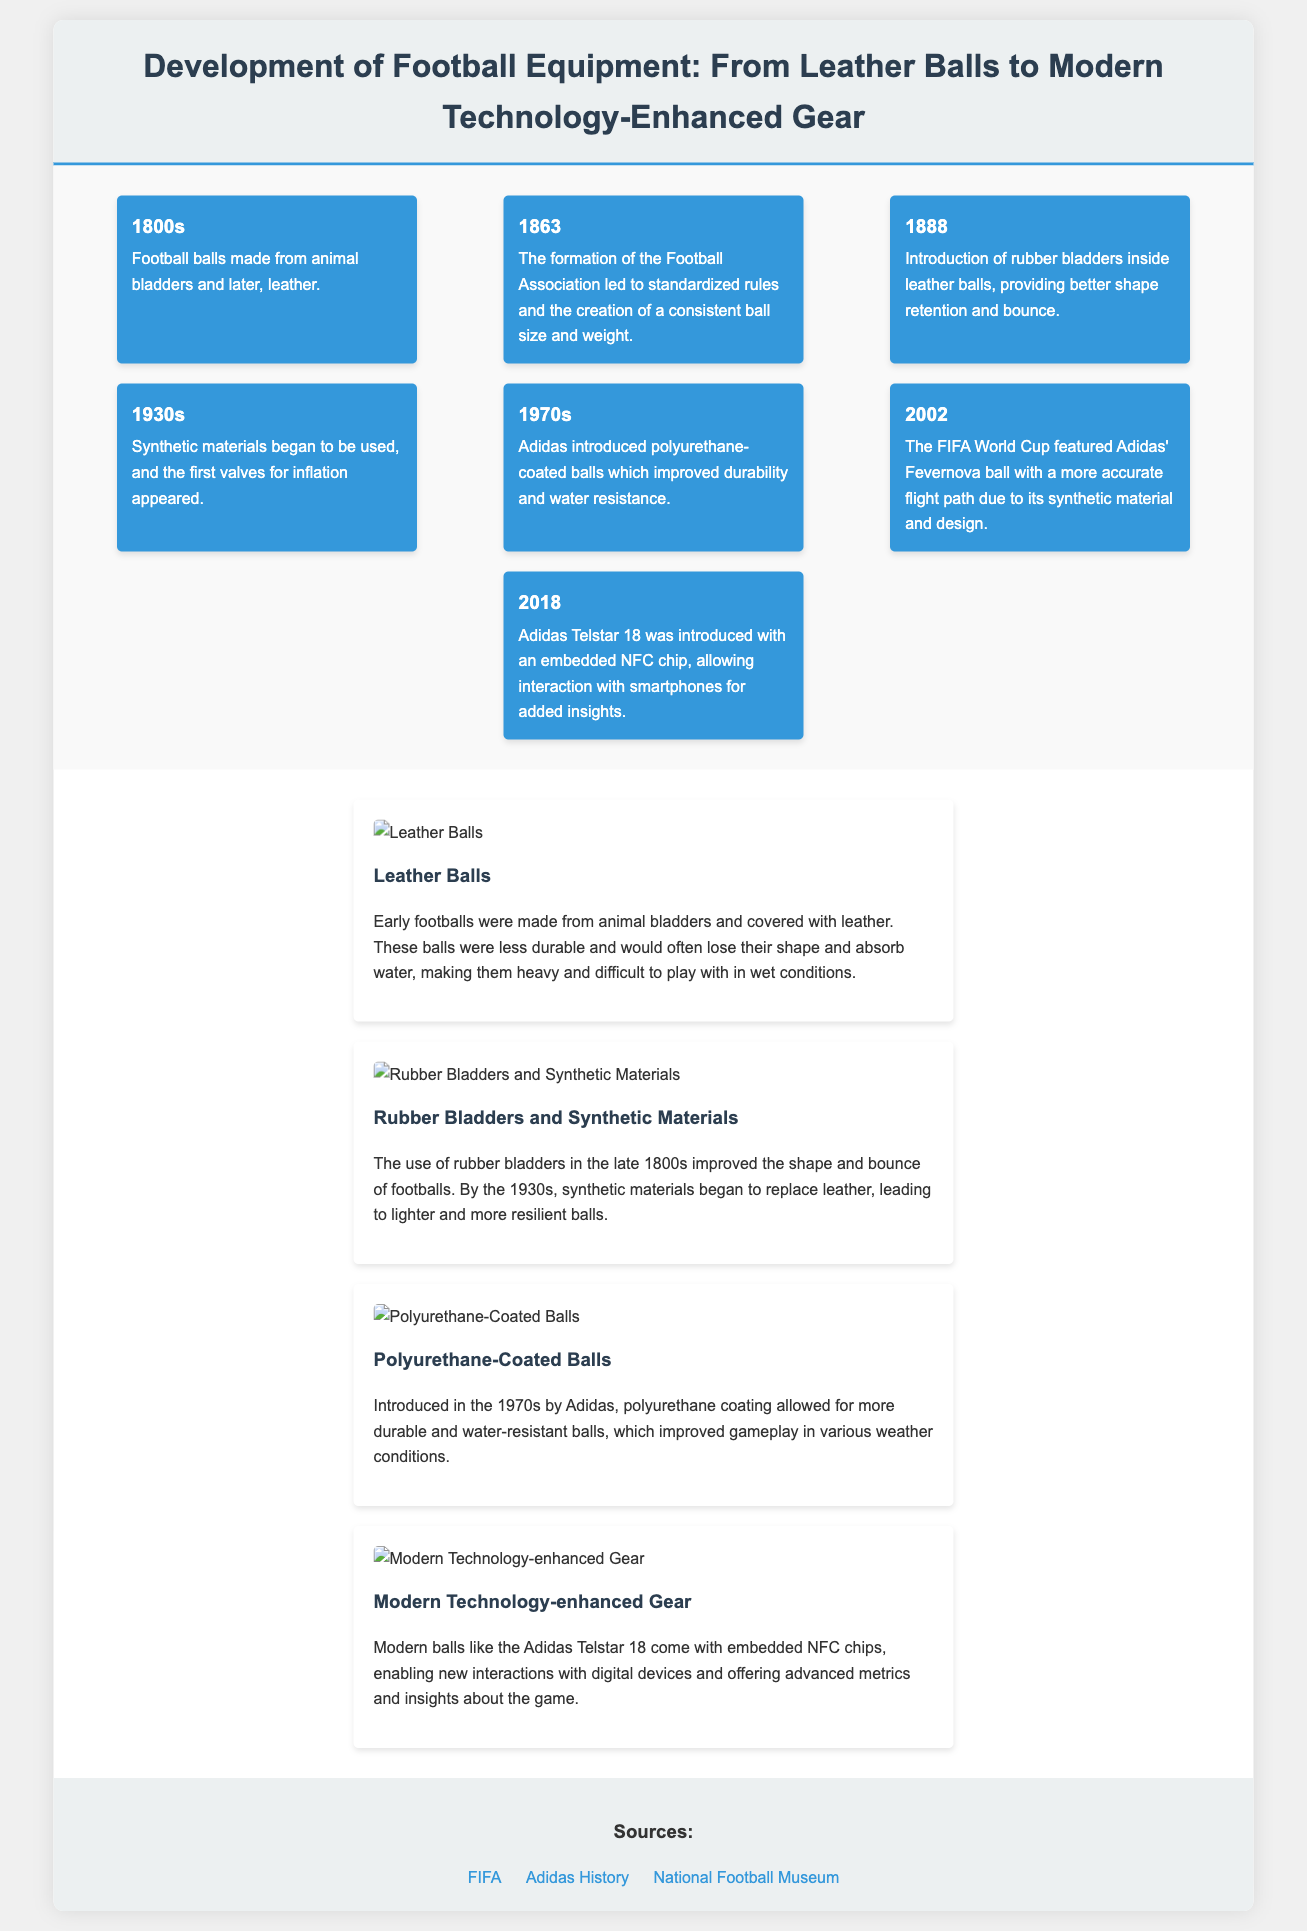What year did the Football Association form? The Football Association was formed in 1863, which led to standardized rules for football.
Answer: 1863 What material was first used inside footballs in 1888? In 1888, rubber bladders were introduced inside leather balls, improving shape retention and bounce.
Answer: Rubber bladders What did the Adidas Fevernova ball feature in 2002? The Adidas Fevernova ball featured a more accurate flight path due to its synthetic material and design.
Answer: Accurate flight path What advantage did polyurethane-coated balls provide since the 1970s? Polyurethane-coated balls improved durability and water resistance, making them better for various weather conditions.
Answer: Durability and water resistance What technological feature does the Adidas Telstar 18 possess? The Adidas Telstar 18 has an embedded NFC chip, allowing interaction with smartphones for added insights.
Answer: Embedded NFC chip How many years passed between the introduction of rubber bladders and the formation of the Football Association? The formation of the Football Association in 1863 and the introduction of rubber bladders in 1888 were 25 years apart.
Answer: 25 years What is the significance of the year 1930s in football equipment development? In the 1930s, synthetic materials began to be used in footballs, along with the introduction of valves for inflation.
Answer: Synthetic materials and valves What type of balls were used in the 1800s? In the 1800s, footballs were made from animal bladders and covered with leather.
Answer: Animal bladders and leather 